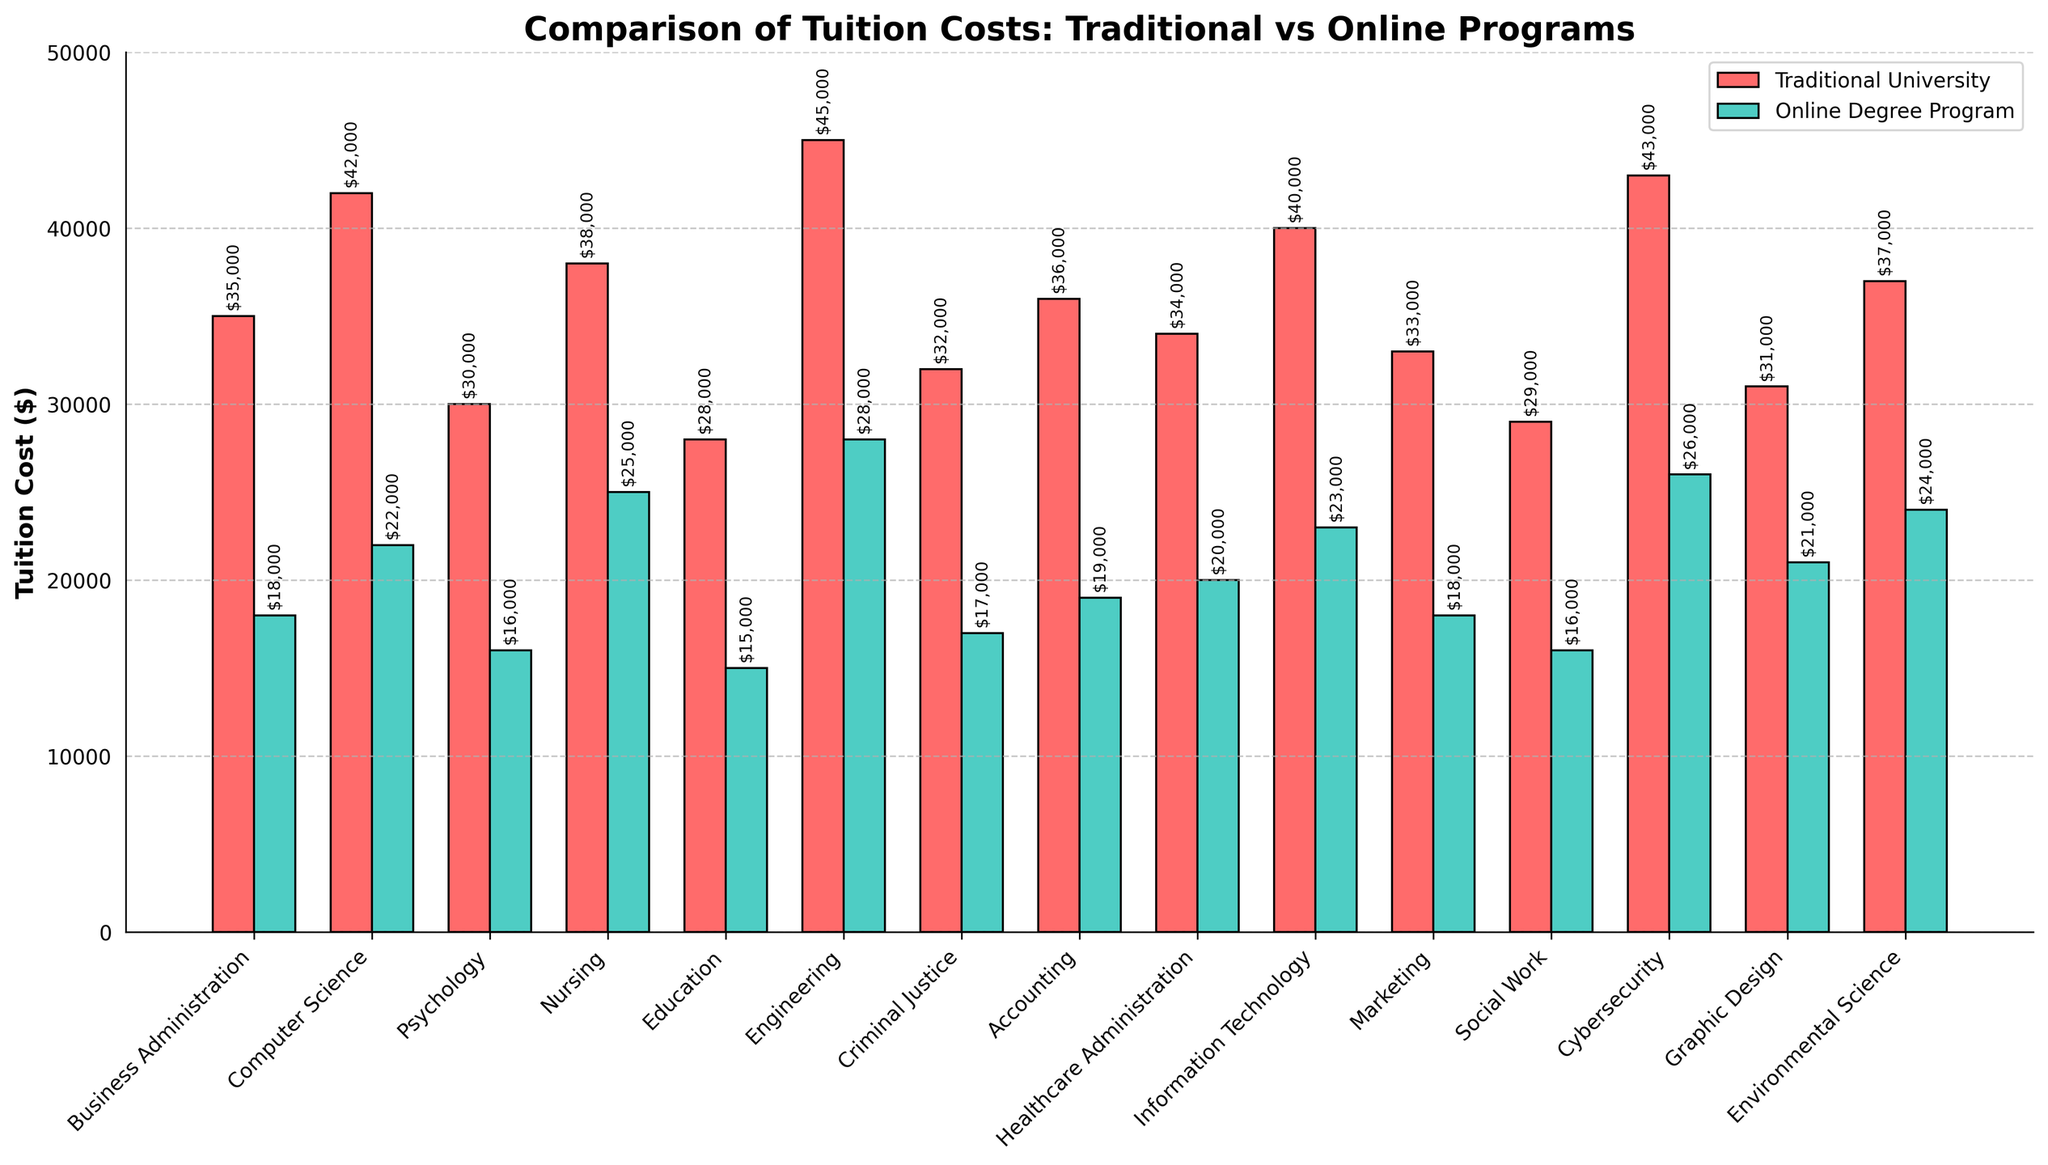Which field has the highest tuition cost for traditional universities? Looking at the bars representing traditional university tuition costs, the tallest bar represents "Engineering" with a cost of $45,000.
Answer: Engineering Which field has the lowest tuition cost for online degree programs? Observing the bars for online degree programs, the shortest bar corresponds to "Education" with a cost of $15,000.
Answer: Education What is the difference in tuition cost between traditional and online programs for Computer Science? For Computer Science, the traditional university tuition is $42,000, and the online degree program tuition is $22,000. The difference is $42,000 - $22,000 = $20,000.
Answer: $20,000 Which field has a smaller difference in tuition costs between traditional and online programs, Social Work or Cybersecurity? For Social Work, the difference is $29,000 (traditional) - $16,000 (online) = $13,000. For Cybersecurity, the difference is $43,000 (traditional) - $26,000 (online) = $17,000. Social Work has a smaller difference of $13,000.
Answer: Social Work How many fields have a traditional university tuition cost above $35,000? Count the bars representing traditional university tuition costs above $35,000: Business Administration, Computer Science, Nursing, Engineering, Information Technology, Cybersecurity, Environmental Science. There are 7 fields.
Answer: 7 What is the average tuition cost for online degree programs across all fields? Sum the online tuition costs and divide by the number of fields: (18000 + 22000 + 16000 + 25000 + 15000 + 28000 + 17000 + 19000 + 20000 + 23000 + 18000 + 16000 + 26000 + 21000 + 24000) / 15 = $21,333.33.
Answer: $21,333.33 Which fields have equal tuition costs for traditional universities and online programs? None of the bars for traditional university tuition cost matches directly with any corresponding bar for online degree program tuition cost. Therefore, no fields have equal costs.
Answer: None Compare the tuition costs for Nursing and Graphic Design in online degree programs. The bar for Nursing in online degree programs shows $25,000, whereas the bar for Graphic Design shows $21,000. Nursing has a higher tuition cost.
Answer: Nursing What is the total tuition cost for traditional universities for the fields of Business Administration, Psychology, and Marketing combined? Add the tuition costs for the respective fields: $35,000 (Business Administration) + $30,000 (Psychology) + $33,000 (Marketing) = $98,000.
Answer: $98,000 